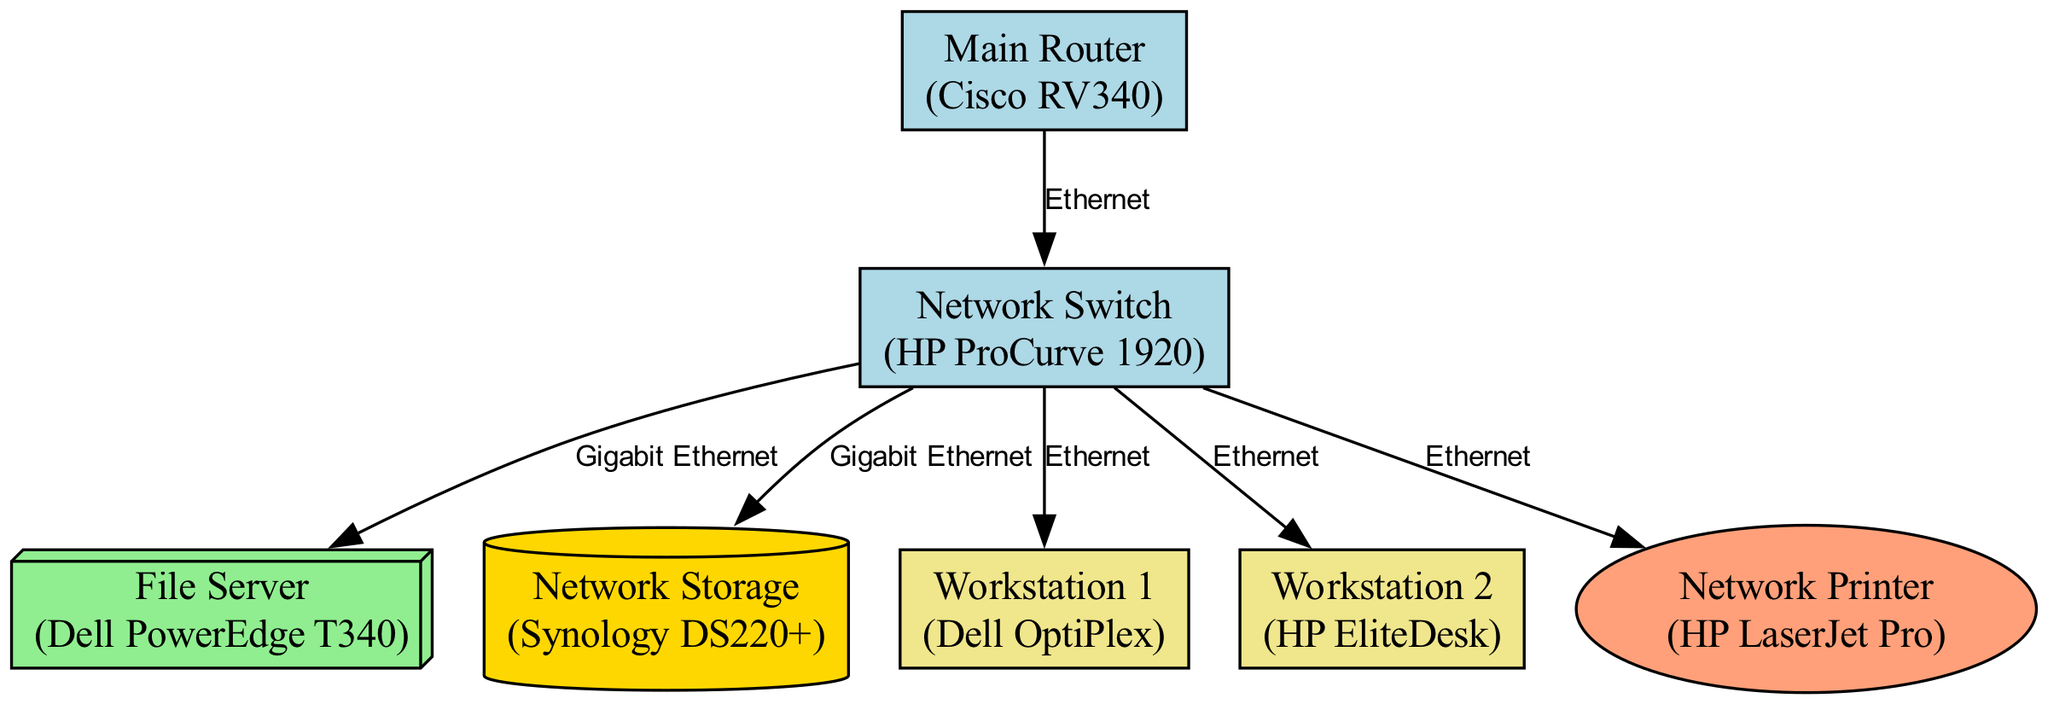What is the main network device in the diagram? The diagram identifies the main network device as the "Main Router (Cisco RV340)" with the ID "router". It is labeled clearly at the top of the diagram.
Answer: Main Router (Cisco RV340) How many workstations are shown in the diagram? By examining the nodes in the diagram, there are two workstations listed: "Workstation 1 (Dell OptiPlex)" and "Workstation 2 (HP EliteDesk)". These are the only workstation nodes depicted.
Answer: 2 What type of connection is used between the router and the switch? The edge connecting the router and the switch is labeled "Ethernet", indicating this is the type of connection utilized in the network.
Answer: Ethernet Which device receives connections from the network switch? The network switch connects to the file server, network storage, two workstations, and a network printer. "File Server (Dell PowerEdge T340)" is one direct connection.
Answer: File Server (Dell PowerEdge T340) What is the type of the network storage device? The network storage is labeled as "Network Storage (Synology DS220+)" and has a specific type of "storage". The label clearly defines it as such within the diagram.
Answer: Network Storage (Synology DS220+) Which type of device is the printer? The diagram specifies the printer as a peripheral device, labeled "Network Printer (HP LaserJet Pro)". This classification distinguishes it from other device types.
Answer: Peripheral How does the network storage connect to the switch? The edge between the switch and the network storage (NAS) device is labeled "Gigabit Ethernet", indicating that this is the type of connection established.
Answer: Gigabit Ethernet How many edges are there in total? By counting the edges listed in the diagram's connections, there are six edges connecting various devices. Each connection represented by an edge indicates a direct link in the network.
Answer: 6 